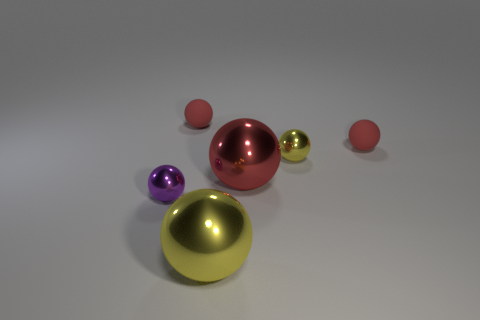Subtract all yellow cylinders. How many red spheres are left? 3 Subtract 3 balls. How many balls are left? 3 Subtract all yellow shiny spheres. How many spheres are left? 4 Subtract all purple spheres. How many spheres are left? 5 Subtract all gray spheres. Subtract all purple cylinders. How many spheres are left? 6 Add 1 yellow metal spheres. How many objects exist? 7 Add 5 purple matte balls. How many purple matte balls exist? 5 Subtract 3 red balls. How many objects are left? 3 Subtract all large spheres. Subtract all yellow metallic spheres. How many objects are left? 2 Add 6 small spheres. How many small spheres are left? 10 